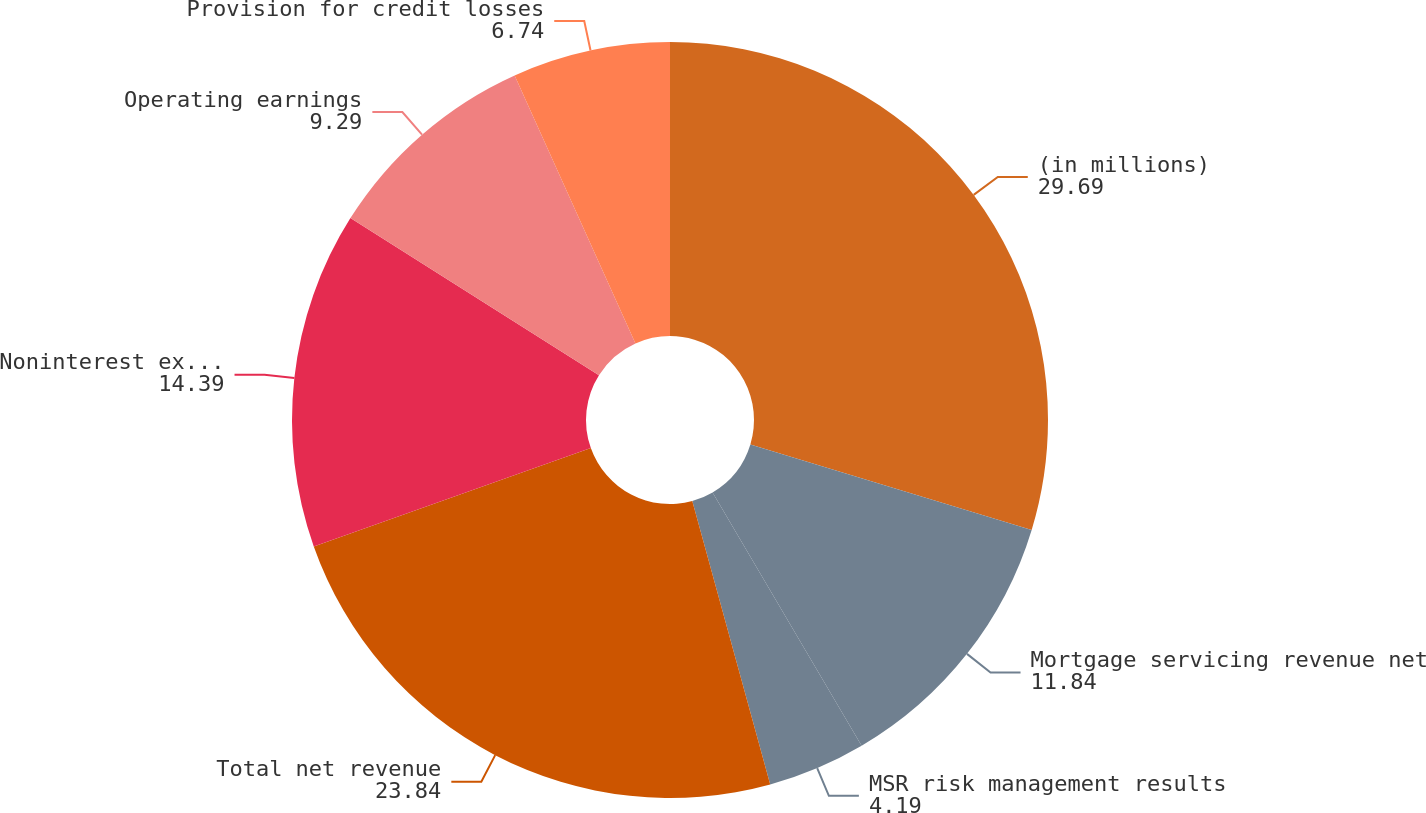Convert chart to OTSL. <chart><loc_0><loc_0><loc_500><loc_500><pie_chart><fcel>(in millions)<fcel>Mortgage servicing revenue net<fcel>MSR risk management results<fcel>Total net revenue<fcel>Noninterest expense<fcel>Operating earnings<fcel>Provision for credit losses<nl><fcel>29.69%<fcel>11.84%<fcel>4.19%<fcel>23.84%<fcel>14.39%<fcel>9.29%<fcel>6.74%<nl></chart> 